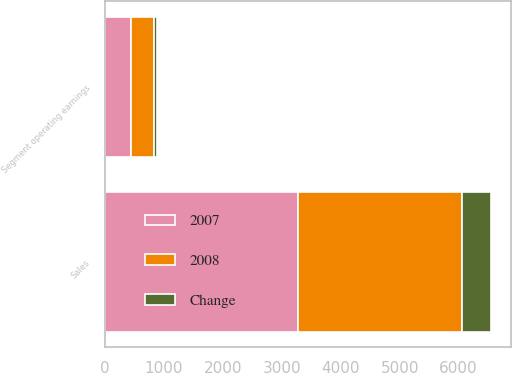<chart> <loc_0><loc_0><loc_500><loc_500><stacked_bar_chart><ecel><fcel>Sales<fcel>Segment operating earnings<nl><fcel>2007<fcel>3278.1<fcel>440.5<nl><fcel>2008<fcel>2782.6<fcel>397<nl><fcel>Change<fcel>495.5<fcel>43.5<nl></chart> 